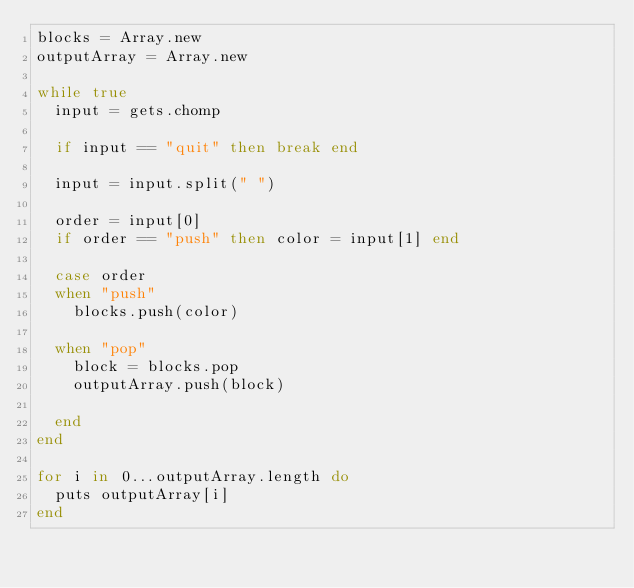<code> <loc_0><loc_0><loc_500><loc_500><_Ruby_>blocks = Array.new
outputArray = Array.new

while true
  input = gets.chomp
  
  if input == "quit" then break end
  
  input = input.split(" ")
  
  order = input[0]
  if order == "push" then color = input[1] end
  
  case order
  when "push"
    blocks.push(color)
	
  when "pop"
    block = blocks.pop
	outputArray.push(block)
	
  end
end

for i in 0...outputArray.length do
  puts outputArray[i]
end</code> 